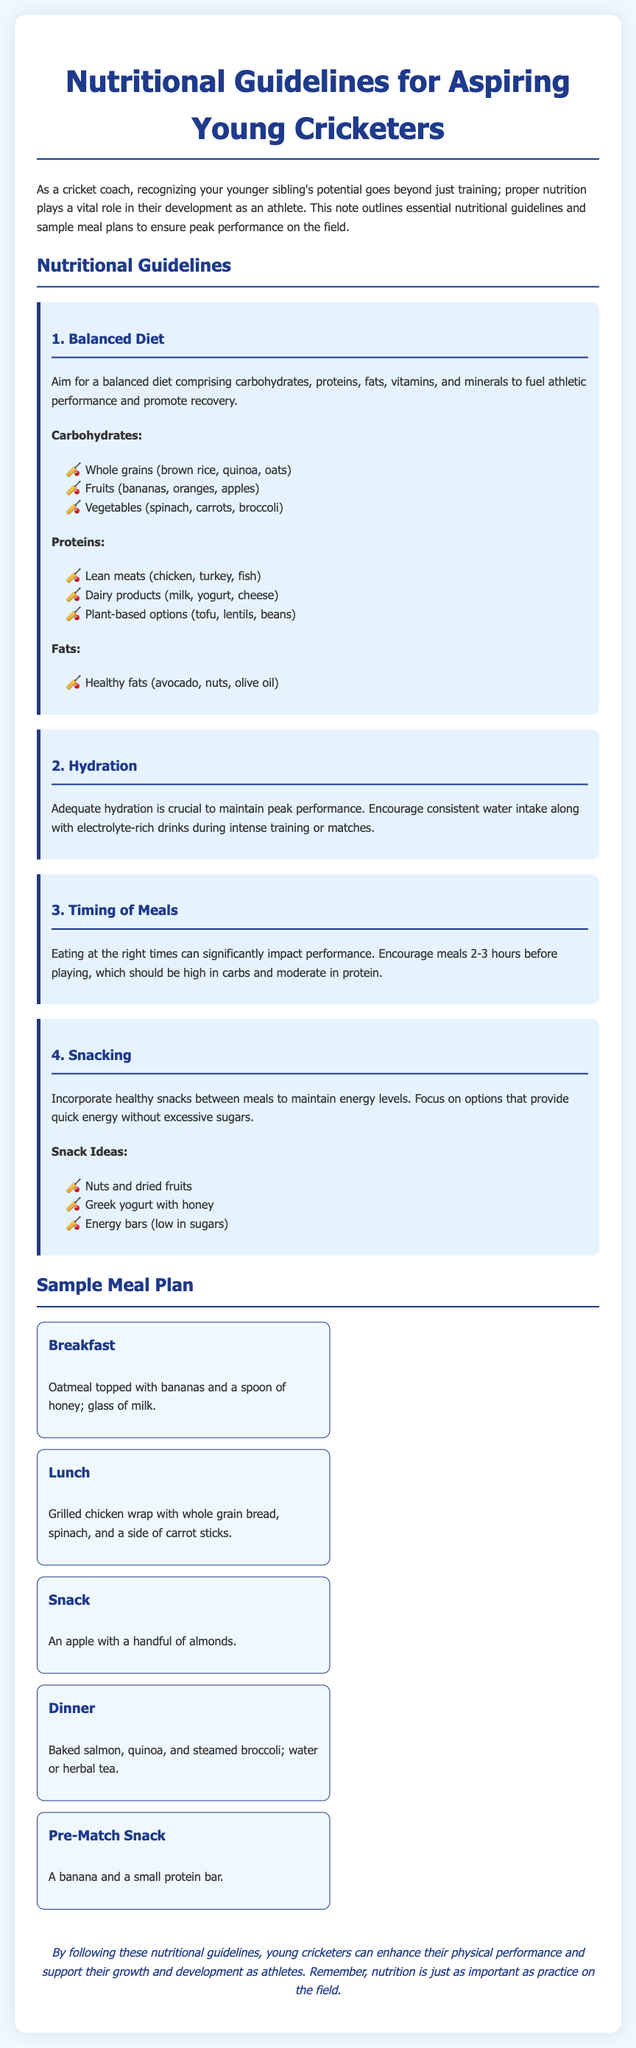What is the title of the document? The title is stated at the top of the document as "Nutritional Guidelines for Aspiring Young Cricketers".
Answer: Nutritional Guidelines for Aspiring Young Cricketers What is the first guideline mentioned? The first guideline discussed in the document is about achieving a balanced diet.
Answer: Balanced Diet What type of fats should young cricketers focus on? The document specifies that young cricketers should focus on healthy fats.
Answer: Healthy fats How many hours before playing should meals ideally be consumed? The document mentions that meals should be eaten 2-3 hours before playing.
Answer: 2-3 hours Name one snack idea for young cricketers. The document lists nuts and dried fruits as one of the snack ideas.
Answer: Nuts and dried fruits What is included in the breakfast sample meal? The document provides details that the breakfast sample includes oatmeal topped with bananas and a spoon of honey.
Answer: Oatmeal topped with bananas and a spoon of honey How many meal examples are provided in the sample meal plan? The document contains a total of five meal examples in the sample meal plan.
Answer: Five What drink is suggested with dinner? The document suggests water or herbal tea with dinner.
Answer: Water or herbal tea What is the concluding thought regarding nutrition? The conclusion emphasizes that nutrition is equally important as practice on the field.
Answer: Nutrition is just as important as practice on the field 